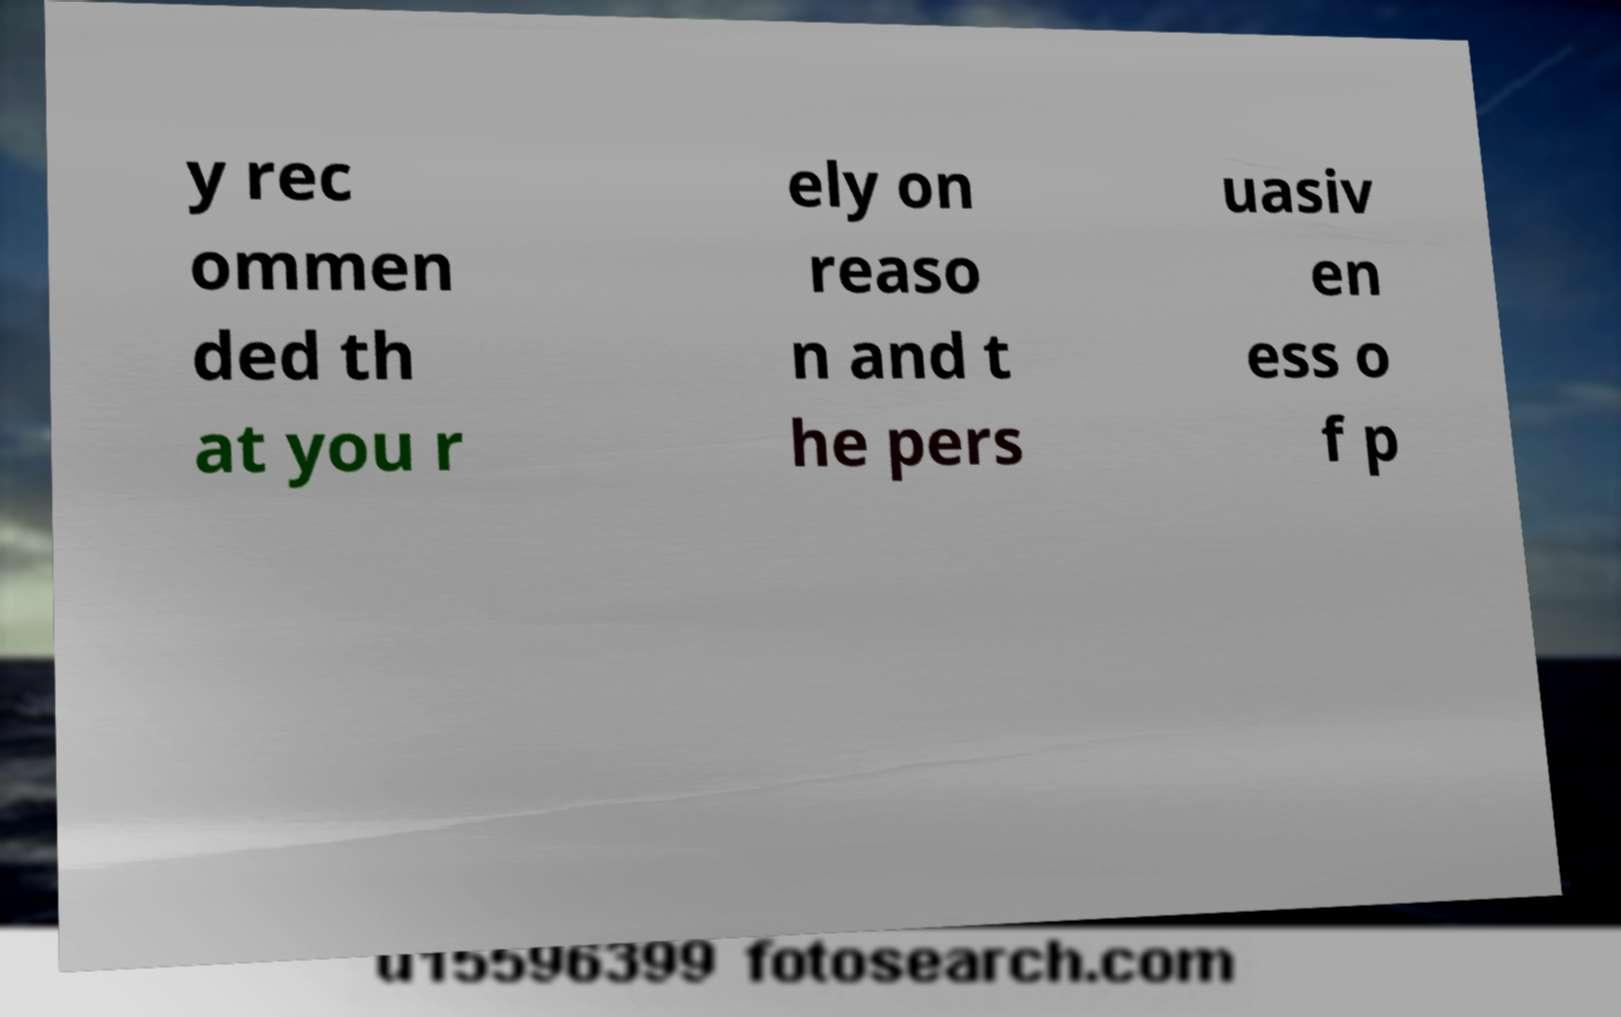I need the written content from this picture converted into text. Can you do that? y rec ommen ded th at you r ely on reaso n and t he pers uasiv en ess o f p 